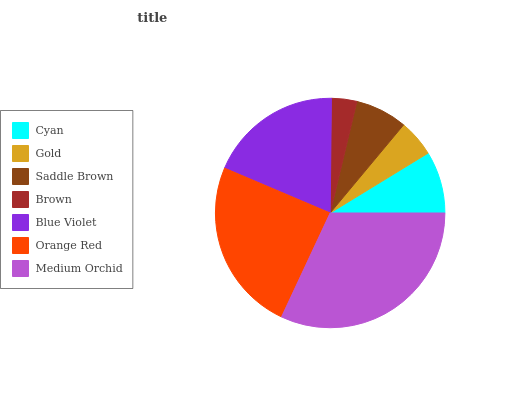Is Brown the minimum?
Answer yes or no. Yes. Is Medium Orchid the maximum?
Answer yes or no. Yes. Is Gold the minimum?
Answer yes or no. No. Is Gold the maximum?
Answer yes or no. No. Is Cyan greater than Gold?
Answer yes or no. Yes. Is Gold less than Cyan?
Answer yes or no. Yes. Is Gold greater than Cyan?
Answer yes or no. No. Is Cyan less than Gold?
Answer yes or no. No. Is Cyan the high median?
Answer yes or no. Yes. Is Cyan the low median?
Answer yes or no. Yes. Is Blue Violet the high median?
Answer yes or no. No. Is Orange Red the low median?
Answer yes or no. No. 